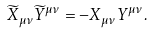<formula> <loc_0><loc_0><loc_500><loc_500>\widetilde { X } _ { \mu \nu } \widetilde { Y } ^ { \mu \nu } = - { X } _ { \mu \nu } { Y } ^ { \mu \nu } .</formula> 